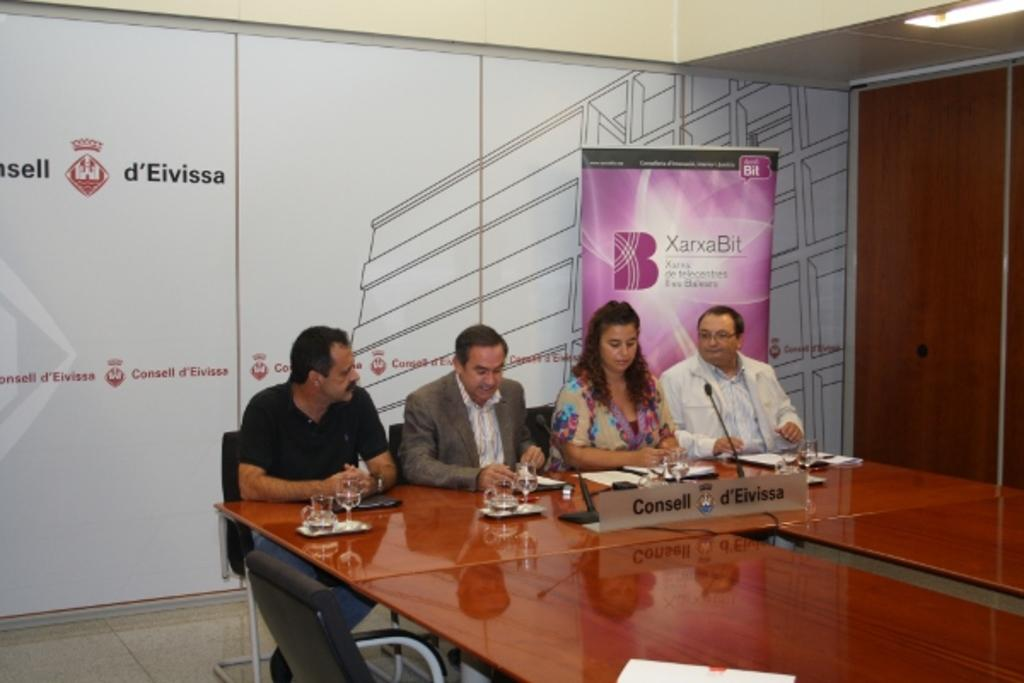What are the people in the image doing? The people in the image are sitting on chairs. What objects are on the table in the image? There are glasses, papers, and two microphones on the table in the image. What type of wrench is being used by the person sitting on the left chair in the image? There is no wrench present in the image. How is the person's brother involved in the scene depicted in the image? The provided facts do not mention any brothers, so we cannot determine their involvement in the scene. 